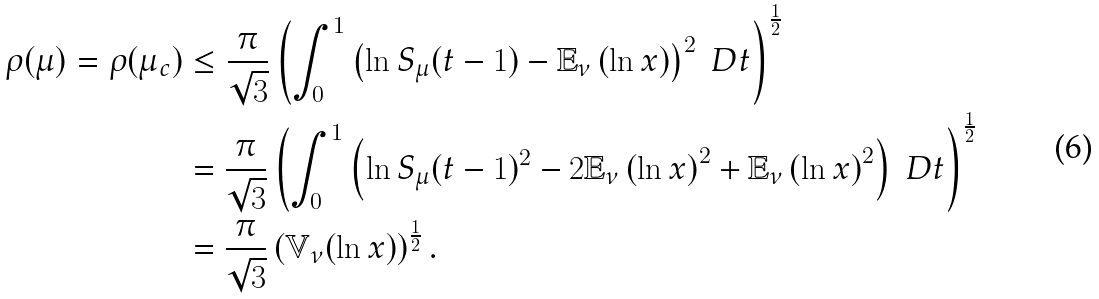Convert formula to latex. <formula><loc_0><loc_0><loc_500><loc_500>\rho ( \mu ) = \rho ( \mu _ { c } ) & \leq \frac { \pi } { \sqrt { 3 } } \left ( \int _ { 0 } ^ { 1 } \left ( \ln S _ { \mu } ( t - 1 ) - \mathbb { E } _ { \nu } \left ( \ln x \right ) \right ) ^ { 2 } \ D t \right ) ^ { \frac { 1 } { 2 } } \\ & = \frac { \pi } { \sqrt { 3 } } \left ( \int _ { 0 } ^ { 1 } \left ( \ln S _ { \mu } ( t - 1 ) ^ { 2 } - 2 \mathbb { E } _ { \nu } \left ( \ln x \right ) ^ { 2 } + \mathbb { E } _ { \nu } \left ( \ln x \right ) ^ { 2 } \right ) \ D t \right ) ^ { \frac { 1 } { 2 } } \\ & = \frac { \pi } { \sqrt { 3 } } \left ( \mathbb { V } _ { \nu } ( \ln x ) \right ) ^ { \frac { 1 } { 2 } } .</formula> 